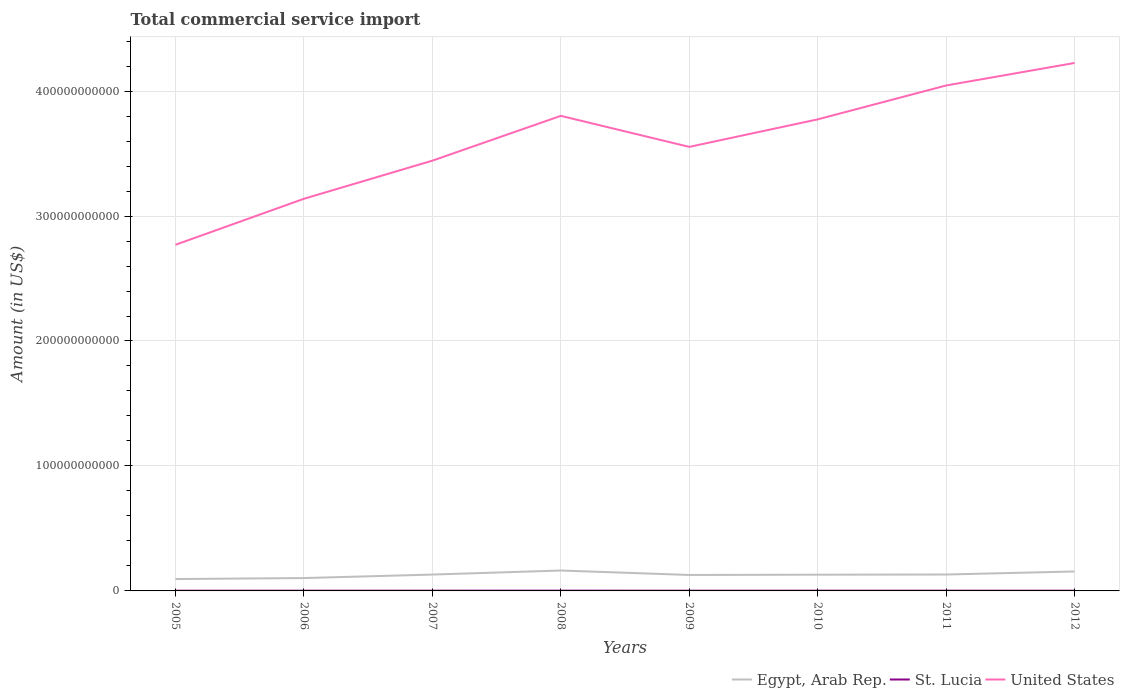Does the line corresponding to United States intersect with the line corresponding to St. Lucia?
Keep it short and to the point. No. Across all years, what is the maximum total commercial service import in St. Lucia?
Offer a very short reply. 1.74e+08. What is the total total commercial service import in Egypt, Arab Rep. in the graph?
Ensure brevity in your answer.  -2.80e+09. What is the difference between the highest and the second highest total commercial service import in United States?
Give a very brief answer. 1.46e+11. Is the total commercial service import in United States strictly greater than the total commercial service import in St. Lucia over the years?
Offer a terse response. No. How many lines are there?
Provide a short and direct response. 3. How many years are there in the graph?
Your answer should be very brief. 8. What is the difference between two consecutive major ticks on the Y-axis?
Your response must be concise. 1.00e+11. Does the graph contain any zero values?
Your answer should be compact. No. Where does the legend appear in the graph?
Provide a short and direct response. Bottom right. What is the title of the graph?
Make the answer very short. Total commercial service import. What is the label or title of the X-axis?
Offer a very short reply. Years. What is the label or title of the Y-axis?
Provide a short and direct response. Amount (in US$). What is the Amount (in US$) of Egypt, Arab Rep. in 2005?
Offer a very short reply. 9.51e+09. What is the Amount (in US$) in St. Lucia in 2005?
Your answer should be compact. 1.74e+08. What is the Amount (in US$) of United States in 2005?
Your answer should be compact. 2.77e+11. What is the Amount (in US$) of Egypt, Arab Rep. in 2006?
Your answer should be very brief. 1.03e+1. What is the Amount (in US$) of St. Lucia in 2006?
Your answer should be compact. 1.82e+08. What is the Amount (in US$) of United States in 2006?
Offer a terse response. 3.14e+11. What is the Amount (in US$) of Egypt, Arab Rep. in 2007?
Offer a terse response. 1.31e+1. What is the Amount (in US$) in St. Lucia in 2007?
Your answer should be very brief. 1.99e+08. What is the Amount (in US$) in United States in 2007?
Offer a terse response. 3.44e+11. What is the Amount (in US$) in Egypt, Arab Rep. in 2008?
Offer a very short reply. 1.63e+1. What is the Amount (in US$) of St. Lucia in 2008?
Your answer should be compact. 2.09e+08. What is the Amount (in US$) of United States in 2008?
Your answer should be compact. 3.80e+11. What is the Amount (in US$) in Egypt, Arab Rep. in 2009?
Your answer should be compact. 1.28e+1. What is the Amount (in US$) of St. Lucia in 2009?
Offer a very short reply. 1.85e+08. What is the Amount (in US$) of United States in 2009?
Offer a very short reply. 3.55e+11. What is the Amount (in US$) in Egypt, Arab Rep. in 2010?
Provide a short and direct response. 1.30e+1. What is the Amount (in US$) in St. Lucia in 2010?
Offer a terse response. 2.00e+08. What is the Amount (in US$) of United States in 2010?
Make the answer very short. 3.77e+11. What is the Amount (in US$) of Egypt, Arab Rep. in 2011?
Your response must be concise. 1.31e+1. What is the Amount (in US$) in St. Lucia in 2011?
Your answer should be compact. 1.97e+08. What is the Amount (in US$) in United States in 2011?
Give a very brief answer. 4.04e+11. What is the Amount (in US$) in Egypt, Arab Rep. in 2012?
Give a very brief answer. 1.56e+1. What is the Amount (in US$) of St. Lucia in 2012?
Your answer should be compact. 1.83e+08. What is the Amount (in US$) in United States in 2012?
Provide a short and direct response. 4.22e+11. Across all years, what is the maximum Amount (in US$) of Egypt, Arab Rep.?
Offer a very short reply. 1.63e+1. Across all years, what is the maximum Amount (in US$) of St. Lucia?
Your response must be concise. 2.09e+08. Across all years, what is the maximum Amount (in US$) in United States?
Provide a succinct answer. 4.22e+11. Across all years, what is the minimum Amount (in US$) of Egypt, Arab Rep.?
Your response must be concise. 9.51e+09. Across all years, what is the minimum Amount (in US$) in St. Lucia?
Ensure brevity in your answer.  1.74e+08. Across all years, what is the minimum Amount (in US$) of United States?
Provide a succinct answer. 2.77e+11. What is the total Amount (in US$) of Egypt, Arab Rep. in the graph?
Your response must be concise. 1.04e+11. What is the total Amount (in US$) of St. Lucia in the graph?
Offer a terse response. 1.53e+09. What is the total Amount (in US$) of United States in the graph?
Provide a short and direct response. 2.87e+12. What is the difference between the Amount (in US$) of Egypt, Arab Rep. in 2005 and that in 2006?
Offer a very short reply. -7.81e+08. What is the difference between the Amount (in US$) in St. Lucia in 2005 and that in 2006?
Your answer should be very brief. -8.19e+06. What is the difference between the Amount (in US$) of United States in 2005 and that in 2006?
Offer a terse response. -3.68e+1. What is the difference between the Amount (in US$) of Egypt, Arab Rep. in 2005 and that in 2007?
Your answer should be very brief. -3.58e+09. What is the difference between the Amount (in US$) in St. Lucia in 2005 and that in 2007?
Your answer should be very brief. -2.51e+07. What is the difference between the Amount (in US$) in United States in 2005 and that in 2007?
Offer a very short reply. -6.73e+1. What is the difference between the Amount (in US$) of Egypt, Arab Rep. in 2005 and that in 2008?
Your answer should be very brief. -6.83e+09. What is the difference between the Amount (in US$) in St. Lucia in 2005 and that in 2008?
Offer a very short reply. -3.48e+07. What is the difference between the Amount (in US$) of United States in 2005 and that in 2008?
Provide a succinct answer. -1.03e+11. What is the difference between the Amount (in US$) of Egypt, Arab Rep. in 2005 and that in 2009?
Ensure brevity in your answer.  -3.26e+09. What is the difference between the Amount (in US$) in St. Lucia in 2005 and that in 2009?
Give a very brief answer. -1.07e+07. What is the difference between the Amount (in US$) in United States in 2005 and that in 2009?
Provide a short and direct response. -7.83e+1. What is the difference between the Amount (in US$) in Egypt, Arab Rep. in 2005 and that in 2010?
Your answer should be very brief. -3.48e+09. What is the difference between the Amount (in US$) of St. Lucia in 2005 and that in 2010?
Offer a terse response. -2.58e+07. What is the difference between the Amount (in US$) of United States in 2005 and that in 2010?
Ensure brevity in your answer.  -1.00e+11. What is the difference between the Amount (in US$) of Egypt, Arab Rep. in 2005 and that in 2011?
Your answer should be very brief. -3.62e+09. What is the difference between the Amount (in US$) in St. Lucia in 2005 and that in 2011?
Your answer should be compact. -2.33e+07. What is the difference between the Amount (in US$) of United States in 2005 and that in 2011?
Keep it short and to the point. -1.27e+11. What is the difference between the Amount (in US$) in Egypt, Arab Rep. in 2005 and that in 2012?
Give a very brief answer. -6.05e+09. What is the difference between the Amount (in US$) of St. Lucia in 2005 and that in 2012?
Provide a succinct answer. -9.31e+06. What is the difference between the Amount (in US$) in United States in 2005 and that in 2012?
Your response must be concise. -1.46e+11. What is the difference between the Amount (in US$) in Egypt, Arab Rep. in 2006 and that in 2007?
Ensure brevity in your answer.  -2.80e+09. What is the difference between the Amount (in US$) in St. Lucia in 2006 and that in 2007?
Make the answer very short. -1.69e+07. What is the difference between the Amount (in US$) of United States in 2006 and that in 2007?
Make the answer very short. -3.05e+1. What is the difference between the Amount (in US$) in Egypt, Arab Rep. in 2006 and that in 2008?
Offer a terse response. -6.05e+09. What is the difference between the Amount (in US$) in St. Lucia in 2006 and that in 2008?
Provide a short and direct response. -2.66e+07. What is the difference between the Amount (in US$) of United States in 2006 and that in 2008?
Your response must be concise. -6.64e+1. What is the difference between the Amount (in US$) in Egypt, Arab Rep. in 2006 and that in 2009?
Make the answer very short. -2.48e+09. What is the difference between the Amount (in US$) in St. Lucia in 2006 and that in 2009?
Make the answer very short. -2.52e+06. What is the difference between the Amount (in US$) of United States in 2006 and that in 2009?
Offer a very short reply. -4.15e+1. What is the difference between the Amount (in US$) in Egypt, Arab Rep. in 2006 and that in 2010?
Provide a succinct answer. -2.70e+09. What is the difference between the Amount (in US$) in St. Lucia in 2006 and that in 2010?
Ensure brevity in your answer.  -1.76e+07. What is the difference between the Amount (in US$) of United States in 2006 and that in 2010?
Offer a terse response. -6.35e+1. What is the difference between the Amount (in US$) in Egypt, Arab Rep. in 2006 and that in 2011?
Your answer should be compact. -2.84e+09. What is the difference between the Amount (in US$) in St. Lucia in 2006 and that in 2011?
Offer a very short reply. -1.51e+07. What is the difference between the Amount (in US$) of United States in 2006 and that in 2011?
Offer a terse response. -9.07e+1. What is the difference between the Amount (in US$) in Egypt, Arab Rep. in 2006 and that in 2012?
Your answer should be compact. -5.27e+09. What is the difference between the Amount (in US$) in St. Lucia in 2006 and that in 2012?
Provide a short and direct response. -1.12e+06. What is the difference between the Amount (in US$) of United States in 2006 and that in 2012?
Provide a short and direct response. -1.09e+11. What is the difference between the Amount (in US$) in Egypt, Arab Rep. in 2007 and that in 2008?
Make the answer very short. -3.25e+09. What is the difference between the Amount (in US$) of St. Lucia in 2007 and that in 2008?
Your answer should be compact. -9.71e+06. What is the difference between the Amount (in US$) in United States in 2007 and that in 2008?
Provide a succinct answer. -3.59e+1. What is the difference between the Amount (in US$) of Egypt, Arab Rep. in 2007 and that in 2009?
Keep it short and to the point. 3.23e+08. What is the difference between the Amount (in US$) in St. Lucia in 2007 and that in 2009?
Provide a succinct answer. 1.44e+07. What is the difference between the Amount (in US$) of United States in 2007 and that in 2009?
Keep it short and to the point. -1.10e+1. What is the difference between the Amount (in US$) in Egypt, Arab Rep. in 2007 and that in 2010?
Make the answer very short. 9.68e+07. What is the difference between the Amount (in US$) of St. Lucia in 2007 and that in 2010?
Give a very brief answer. -6.63e+05. What is the difference between the Amount (in US$) in United States in 2007 and that in 2010?
Make the answer very short. -3.30e+1. What is the difference between the Amount (in US$) in Egypt, Arab Rep. in 2007 and that in 2011?
Provide a short and direct response. -4.13e+07. What is the difference between the Amount (in US$) in St. Lucia in 2007 and that in 2011?
Give a very brief answer. 1.82e+06. What is the difference between the Amount (in US$) of United States in 2007 and that in 2011?
Offer a terse response. -6.02e+1. What is the difference between the Amount (in US$) in Egypt, Arab Rep. in 2007 and that in 2012?
Make the answer very short. -2.47e+09. What is the difference between the Amount (in US$) of St. Lucia in 2007 and that in 2012?
Your answer should be very brief. 1.58e+07. What is the difference between the Amount (in US$) of United States in 2007 and that in 2012?
Keep it short and to the point. -7.82e+1. What is the difference between the Amount (in US$) of Egypt, Arab Rep. in 2008 and that in 2009?
Make the answer very short. 3.57e+09. What is the difference between the Amount (in US$) in St. Lucia in 2008 and that in 2009?
Keep it short and to the point. 2.41e+07. What is the difference between the Amount (in US$) in United States in 2008 and that in 2009?
Make the answer very short. 2.48e+1. What is the difference between the Amount (in US$) in Egypt, Arab Rep. in 2008 and that in 2010?
Keep it short and to the point. 3.34e+09. What is the difference between the Amount (in US$) of St. Lucia in 2008 and that in 2010?
Make the answer very short. 9.05e+06. What is the difference between the Amount (in US$) of United States in 2008 and that in 2010?
Your answer should be compact. 2.82e+09. What is the difference between the Amount (in US$) in Egypt, Arab Rep. in 2008 and that in 2011?
Offer a terse response. 3.21e+09. What is the difference between the Amount (in US$) in St. Lucia in 2008 and that in 2011?
Provide a succinct answer. 1.15e+07. What is the difference between the Amount (in US$) of United States in 2008 and that in 2011?
Offer a terse response. -2.43e+1. What is the difference between the Amount (in US$) of Egypt, Arab Rep. in 2008 and that in 2012?
Give a very brief answer. 7.78e+08. What is the difference between the Amount (in US$) of St. Lucia in 2008 and that in 2012?
Make the answer very short. 2.55e+07. What is the difference between the Amount (in US$) in United States in 2008 and that in 2012?
Ensure brevity in your answer.  -4.23e+1. What is the difference between the Amount (in US$) in Egypt, Arab Rep. in 2009 and that in 2010?
Your answer should be compact. -2.26e+08. What is the difference between the Amount (in US$) of St. Lucia in 2009 and that in 2010?
Ensure brevity in your answer.  -1.51e+07. What is the difference between the Amount (in US$) of United States in 2009 and that in 2010?
Offer a very short reply. -2.20e+1. What is the difference between the Amount (in US$) of Egypt, Arab Rep. in 2009 and that in 2011?
Provide a short and direct response. -3.64e+08. What is the difference between the Amount (in US$) of St. Lucia in 2009 and that in 2011?
Make the answer very short. -1.26e+07. What is the difference between the Amount (in US$) in United States in 2009 and that in 2011?
Ensure brevity in your answer.  -4.91e+1. What is the difference between the Amount (in US$) in Egypt, Arab Rep. in 2009 and that in 2012?
Provide a succinct answer. -2.79e+09. What is the difference between the Amount (in US$) in St. Lucia in 2009 and that in 2012?
Offer a very short reply. 1.40e+06. What is the difference between the Amount (in US$) of United States in 2009 and that in 2012?
Provide a short and direct response. -6.72e+1. What is the difference between the Amount (in US$) of Egypt, Arab Rep. in 2010 and that in 2011?
Your answer should be very brief. -1.38e+08. What is the difference between the Amount (in US$) of St. Lucia in 2010 and that in 2011?
Make the answer very short. 2.48e+06. What is the difference between the Amount (in US$) in United States in 2010 and that in 2011?
Your answer should be very brief. -2.71e+1. What is the difference between the Amount (in US$) in Egypt, Arab Rep. in 2010 and that in 2012?
Offer a very short reply. -2.57e+09. What is the difference between the Amount (in US$) in St. Lucia in 2010 and that in 2012?
Give a very brief answer. 1.65e+07. What is the difference between the Amount (in US$) in United States in 2010 and that in 2012?
Your response must be concise. -4.51e+1. What is the difference between the Amount (in US$) of Egypt, Arab Rep. in 2011 and that in 2012?
Keep it short and to the point. -2.43e+09. What is the difference between the Amount (in US$) of St. Lucia in 2011 and that in 2012?
Give a very brief answer. 1.40e+07. What is the difference between the Amount (in US$) in United States in 2011 and that in 2012?
Make the answer very short. -1.80e+1. What is the difference between the Amount (in US$) in Egypt, Arab Rep. in 2005 and the Amount (in US$) in St. Lucia in 2006?
Give a very brief answer. 9.33e+09. What is the difference between the Amount (in US$) of Egypt, Arab Rep. in 2005 and the Amount (in US$) of United States in 2006?
Ensure brevity in your answer.  -3.04e+11. What is the difference between the Amount (in US$) of St. Lucia in 2005 and the Amount (in US$) of United States in 2006?
Your answer should be very brief. -3.14e+11. What is the difference between the Amount (in US$) of Egypt, Arab Rep. in 2005 and the Amount (in US$) of St. Lucia in 2007?
Give a very brief answer. 9.31e+09. What is the difference between the Amount (in US$) in Egypt, Arab Rep. in 2005 and the Amount (in US$) in United States in 2007?
Your response must be concise. -3.35e+11. What is the difference between the Amount (in US$) of St. Lucia in 2005 and the Amount (in US$) of United States in 2007?
Your answer should be compact. -3.44e+11. What is the difference between the Amount (in US$) of Egypt, Arab Rep. in 2005 and the Amount (in US$) of St. Lucia in 2008?
Your answer should be very brief. 9.30e+09. What is the difference between the Amount (in US$) in Egypt, Arab Rep. in 2005 and the Amount (in US$) in United States in 2008?
Make the answer very short. -3.71e+11. What is the difference between the Amount (in US$) in St. Lucia in 2005 and the Amount (in US$) in United States in 2008?
Give a very brief answer. -3.80e+11. What is the difference between the Amount (in US$) of Egypt, Arab Rep. in 2005 and the Amount (in US$) of St. Lucia in 2009?
Provide a short and direct response. 9.32e+09. What is the difference between the Amount (in US$) in Egypt, Arab Rep. in 2005 and the Amount (in US$) in United States in 2009?
Offer a very short reply. -3.46e+11. What is the difference between the Amount (in US$) in St. Lucia in 2005 and the Amount (in US$) in United States in 2009?
Your response must be concise. -3.55e+11. What is the difference between the Amount (in US$) of Egypt, Arab Rep. in 2005 and the Amount (in US$) of St. Lucia in 2010?
Provide a succinct answer. 9.31e+09. What is the difference between the Amount (in US$) in Egypt, Arab Rep. in 2005 and the Amount (in US$) in United States in 2010?
Give a very brief answer. -3.68e+11. What is the difference between the Amount (in US$) of St. Lucia in 2005 and the Amount (in US$) of United States in 2010?
Ensure brevity in your answer.  -3.77e+11. What is the difference between the Amount (in US$) in Egypt, Arab Rep. in 2005 and the Amount (in US$) in St. Lucia in 2011?
Your answer should be compact. 9.31e+09. What is the difference between the Amount (in US$) in Egypt, Arab Rep. in 2005 and the Amount (in US$) in United States in 2011?
Your answer should be very brief. -3.95e+11. What is the difference between the Amount (in US$) of St. Lucia in 2005 and the Amount (in US$) of United States in 2011?
Ensure brevity in your answer.  -4.04e+11. What is the difference between the Amount (in US$) in Egypt, Arab Rep. in 2005 and the Amount (in US$) in St. Lucia in 2012?
Offer a terse response. 9.32e+09. What is the difference between the Amount (in US$) in Egypt, Arab Rep. in 2005 and the Amount (in US$) in United States in 2012?
Offer a very short reply. -4.13e+11. What is the difference between the Amount (in US$) of St. Lucia in 2005 and the Amount (in US$) of United States in 2012?
Your answer should be compact. -4.22e+11. What is the difference between the Amount (in US$) in Egypt, Arab Rep. in 2006 and the Amount (in US$) in St. Lucia in 2007?
Offer a terse response. 1.01e+1. What is the difference between the Amount (in US$) in Egypt, Arab Rep. in 2006 and the Amount (in US$) in United States in 2007?
Make the answer very short. -3.34e+11. What is the difference between the Amount (in US$) in St. Lucia in 2006 and the Amount (in US$) in United States in 2007?
Give a very brief answer. -3.44e+11. What is the difference between the Amount (in US$) in Egypt, Arab Rep. in 2006 and the Amount (in US$) in St. Lucia in 2008?
Offer a very short reply. 1.01e+1. What is the difference between the Amount (in US$) of Egypt, Arab Rep. in 2006 and the Amount (in US$) of United States in 2008?
Keep it short and to the point. -3.70e+11. What is the difference between the Amount (in US$) in St. Lucia in 2006 and the Amount (in US$) in United States in 2008?
Make the answer very short. -3.80e+11. What is the difference between the Amount (in US$) of Egypt, Arab Rep. in 2006 and the Amount (in US$) of St. Lucia in 2009?
Offer a terse response. 1.01e+1. What is the difference between the Amount (in US$) of Egypt, Arab Rep. in 2006 and the Amount (in US$) of United States in 2009?
Give a very brief answer. -3.45e+11. What is the difference between the Amount (in US$) of St. Lucia in 2006 and the Amount (in US$) of United States in 2009?
Your answer should be very brief. -3.55e+11. What is the difference between the Amount (in US$) of Egypt, Arab Rep. in 2006 and the Amount (in US$) of St. Lucia in 2010?
Your answer should be very brief. 1.01e+1. What is the difference between the Amount (in US$) in Egypt, Arab Rep. in 2006 and the Amount (in US$) in United States in 2010?
Make the answer very short. -3.67e+11. What is the difference between the Amount (in US$) of St. Lucia in 2006 and the Amount (in US$) of United States in 2010?
Provide a succinct answer. -3.77e+11. What is the difference between the Amount (in US$) of Egypt, Arab Rep. in 2006 and the Amount (in US$) of St. Lucia in 2011?
Your answer should be very brief. 1.01e+1. What is the difference between the Amount (in US$) in Egypt, Arab Rep. in 2006 and the Amount (in US$) in United States in 2011?
Your answer should be compact. -3.94e+11. What is the difference between the Amount (in US$) of St. Lucia in 2006 and the Amount (in US$) of United States in 2011?
Ensure brevity in your answer.  -4.04e+11. What is the difference between the Amount (in US$) of Egypt, Arab Rep. in 2006 and the Amount (in US$) of St. Lucia in 2012?
Give a very brief answer. 1.01e+1. What is the difference between the Amount (in US$) of Egypt, Arab Rep. in 2006 and the Amount (in US$) of United States in 2012?
Provide a short and direct response. -4.12e+11. What is the difference between the Amount (in US$) in St. Lucia in 2006 and the Amount (in US$) in United States in 2012?
Give a very brief answer. -4.22e+11. What is the difference between the Amount (in US$) of Egypt, Arab Rep. in 2007 and the Amount (in US$) of St. Lucia in 2008?
Make the answer very short. 1.29e+1. What is the difference between the Amount (in US$) of Egypt, Arab Rep. in 2007 and the Amount (in US$) of United States in 2008?
Give a very brief answer. -3.67e+11. What is the difference between the Amount (in US$) in St. Lucia in 2007 and the Amount (in US$) in United States in 2008?
Ensure brevity in your answer.  -3.80e+11. What is the difference between the Amount (in US$) in Egypt, Arab Rep. in 2007 and the Amount (in US$) in St. Lucia in 2009?
Provide a short and direct response. 1.29e+1. What is the difference between the Amount (in US$) of Egypt, Arab Rep. in 2007 and the Amount (in US$) of United States in 2009?
Provide a short and direct response. -3.42e+11. What is the difference between the Amount (in US$) in St. Lucia in 2007 and the Amount (in US$) in United States in 2009?
Make the answer very short. -3.55e+11. What is the difference between the Amount (in US$) of Egypt, Arab Rep. in 2007 and the Amount (in US$) of St. Lucia in 2010?
Provide a succinct answer. 1.29e+1. What is the difference between the Amount (in US$) of Egypt, Arab Rep. in 2007 and the Amount (in US$) of United States in 2010?
Offer a terse response. -3.64e+11. What is the difference between the Amount (in US$) of St. Lucia in 2007 and the Amount (in US$) of United States in 2010?
Offer a terse response. -3.77e+11. What is the difference between the Amount (in US$) of Egypt, Arab Rep. in 2007 and the Amount (in US$) of St. Lucia in 2011?
Make the answer very short. 1.29e+1. What is the difference between the Amount (in US$) in Egypt, Arab Rep. in 2007 and the Amount (in US$) in United States in 2011?
Offer a terse response. -3.91e+11. What is the difference between the Amount (in US$) of St. Lucia in 2007 and the Amount (in US$) of United States in 2011?
Your response must be concise. -4.04e+11. What is the difference between the Amount (in US$) in Egypt, Arab Rep. in 2007 and the Amount (in US$) in St. Lucia in 2012?
Provide a succinct answer. 1.29e+1. What is the difference between the Amount (in US$) in Egypt, Arab Rep. in 2007 and the Amount (in US$) in United States in 2012?
Make the answer very short. -4.09e+11. What is the difference between the Amount (in US$) in St. Lucia in 2007 and the Amount (in US$) in United States in 2012?
Give a very brief answer. -4.22e+11. What is the difference between the Amount (in US$) of Egypt, Arab Rep. in 2008 and the Amount (in US$) of St. Lucia in 2009?
Your answer should be compact. 1.62e+1. What is the difference between the Amount (in US$) of Egypt, Arab Rep. in 2008 and the Amount (in US$) of United States in 2009?
Your response must be concise. -3.39e+11. What is the difference between the Amount (in US$) in St. Lucia in 2008 and the Amount (in US$) in United States in 2009?
Ensure brevity in your answer.  -3.55e+11. What is the difference between the Amount (in US$) in Egypt, Arab Rep. in 2008 and the Amount (in US$) in St. Lucia in 2010?
Make the answer very short. 1.61e+1. What is the difference between the Amount (in US$) in Egypt, Arab Rep. in 2008 and the Amount (in US$) in United States in 2010?
Give a very brief answer. -3.61e+11. What is the difference between the Amount (in US$) of St. Lucia in 2008 and the Amount (in US$) of United States in 2010?
Make the answer very short. -3.77e+11. What is the difference between the Amount (in US$) of Egypt, Arab Rep. in 2008 and the Amount (in US$) of St. Lucia in 2011?
Provide a succinct answer. 1.61e+1. What is the difference between the Amount (in US$) of Egypt, Arab Rep. in 2008 and the Amount (in US$) of United States in 2011?
Your response must be concise. -3.88e+11. What is the difference between the Amount (in US$) of St. Lucia in 2008 and the Amount (in US$) of United States in 2011?
Keep it short and to the point. -4.04e+11. What is the difference between the Amount (in US$) in Egypt, Arab Rep. in 2008 and the Amount (in US$) in St. Lucia in 2012?
Offer a terse response. 1.62e+1. What is the difference between the Amount (in US$) of Egypt, Arab Rep. in 2008 and the Amount (in US$) of United States in 2012?
Your answer should be very brief. -4.06e+11. What is the difference between the Amount (in US$) in St. Lucia in 2008 and the Amount (in US$) in United States in 2012?
Make the answer very short. -4.22e+11. What is the difference between the Amount (in US$) of Egypt, Arab Rep. in 2009 and the Amount (in US$) of St. Lucia in 2010?
Give a very brief answer. 1.26e+1. What is the difference between the Amount (in US$) in Egypt, Arab Rep. in 2009 and the Amount (in US$) in United States in 2010?
Offer a very short reply. -3.65e+11. What is the difference between the Amount (in US$) of St. Lucia in 2009 and the Amount (in US$) of United States in 2010?
Your response must be concise. -3.77e+11. What is the difference between the Amount (in US$) of Egypt, Arab Rep. in 2009 and the Amount (in US$) of St. Lucia in 2011?
Your answer should be very brief. 1.26e+1. What is the difference between the Amount (in US$) of Egypt, Arab Rep. in 2009 and the Amount (in US$) of United States in 2011?
Your response must be concise. -3.92e+11. What is the difference between the Amount (in US$) of St. Lucia in 2009 and the Amount (in US$) of United States in 2011?
Make the answer very short. -4.04e+11. What is the difference between the Amount (in US$) of Egypt, Arab Rep. in 2009 and the Amount (in US$) of St. Lucia in 2012?
Offer a very short reply. 1.26e+1. What is the difference between the Amount (in US$) of Egypt, Arab Rep. in 2009 and the Amount (in US$) of United States in 2012?
Your answer should be very brief. -4.10e+11. What is the difference between the Amount (in US$) in St. Lucia in 2009 and the Amount (in US$) in United States in 2012?
Your response must be concise. -4.22e+11. What is the difference between the Amount (in US$) of Egypt, Arab Rep. in 2010 and the Amount (in US$) of St. Lucia in 2011?
Your answer should be compact. 1.28e+1. What is the difference between the Amount (in US$) of Egypt, Arab Rep. in 2010 and the Amount (in US$) of United States in 2011?
Ensure brevity in your answer.  -3.91e+11. What is the difference between the Amount (in US$) in St. Lucia in 2010 and the Amount (in US$) in United States in 2011?
Give a very brief answer. -4.04e+11. What is the difference between the Amount (in US$) of Egypt, Arab Rep. in 2010 and the Amount (in US$) of St. Lucia in 2012?
Provide a short and direct response. 1.28e+1. What is the difference between the Amount (in US$) in Egypt, Arab Rep. in 2010 and the Amount (in US$) in United States in 2012?
Keep it short and to the point. -4.10e+11. What is the difference between the Amount (in US$) of St. Lucia in 2010 and the Amount (in US$) of United States in 2012?
Make the answer very short. -4.22e+11. What is the difference between the Amount (in US$) of Egypt, Arab Rep. in 2011 and the Amount (in US$) of St. Lucia in 2012?
Your answer should be very brief. 1.29e+1. What is the difference between the Amount (in US$) in Egypt, Arab Rep. in 2011 and the Amount (in US$) in United States in 2012?
Provide a succinct answer. -4.09e+11. What is the difference between the Amount (in US$) of St. Lucia in 2011 and the Amount (in US$) of United States in 2012?
Your answer should be compact. -4.22e+11. What is the average Amount (in US$) of Egypt, Arab Rep. per year?
Your answer should be compact. 1.30e+1. What is the average Amount (in US$) in St. Lucia per year?
Your answer should be very brief. 1.91e+08. What is the average Amount (in US$) in United States per year?
Make the answer very short. 3.59e+11. In the year 2005, what is the difference between the Amount (in US$) in Egypt, Arab Rep. and Amount (in US$) in St. Lucia?
Make the answer very short. 9.33e+09. In the year 2005, what is the difference between the Amount (in US$) in Egypt, Arab Rep. and Amount (in US$) in United States?
Offer a very short reply. -2.67e+11. In the year 2005, what is the difference between the Amount (in US$) in St. Lucia and Amount (in US$) in United States?
Offer a terse response. -2.77e+11. In the year 2006, what is the difference between the Amount (in US$) in Egypt, Arab Rep. and Amount (in US$) in St. Lucia?
Your answer should be compact. 1.01e+1. In the year 2006, what is the difference between the Amount (in US$) of Egypt, Arab Rep. and Amount (in US$) of United States?
Provide a short and direct response. -3.04e+11. In the year 2006, what is the difference between the Amount (in US$) in St. Lucia and Amount (in US$) in United States?
Make the answer very short. -3.14e+11. In the year 2007, what is the difference between the Amount (in US$) of Egypt, Arab Rep. and Amount (in US$) of St. Lucia?
Your response must be concise. 1.29e+1. In the year 2007, what is the difference between the Amount (in US$) of Egypt, Arab Rep. and Amount (in US$) of United States?
Keep it short and to the point. -3.31e+11. In the year 2007, what is the difference between the Amount (in US$) of St. Lucia and Amount (in US$) of United States?
Provide a succinct answer. -3.44e+11. In the year 2008, what is the difference between the Amount (in US$) in Egypt, Arab Rep. and Amount (in US$) in St. Lucia?
Your answer should be compact. 1.61e+1. In the year 2008, what is the difference between the Amount (in US$) of Egypt, Arab Rep. and Amount (in US$) of United States?
Make the answer very short. -3.64e+11. In the year 2008, what is the difference between the Amount (in US$) of St. Lucia and Amount (in US$) of United States?
Keep it short and to the point. -3.80e+11. In the year 2009, what is the difference between the Amount (in US$) in Egypt, Arab Rep. and Amount (in US$) in St. Lucia?
Keep it short and to the point. 1.26e+1. In the year 2009, what is the difference between the Amount (in US$) of Egypt, Arab Rep. and Amount (in US$) of United States?
Offer a terse response. -3.43e+11. In the year 2009, what is the difference between the Amount (in US$) in St. Lucia and Amount (in US$) in United States?
Your response must be concise. -3.55e+11. In the year 2010, what is the difference between the Amount (in US$) of Egypt, Arab Rep. and Amount (in US$) of St. Lucia?
Your answer should be very brief. 1.28e+1. In the year 2010, what is the difference between the Amount (in US$) of Egypt, Arab Rep. and Amount (in US$) of United States?
Offer a very short reply. -3.64e+11. In the year 2010, what is the difference between the Amount (in US$) of St. Lucia and Amount (in US$) of United States?
Ensure brevity in your answer.  -3.77e+11. In the year 2011, what is the difference between the Amount (in US$) of Egypt, Arab Rep. and Amount (in US$) of St. Lucia?
Your answer should be compact. 1.29e+1. In the year 2011, what is the difference between the Amount (in US$) in Egypt, Arab Rep. and Amount (in US$) in United States?
Your answer should be compact. -3.91e+11. In the year 2011, what is the difference between the Amount (in US$) of St. Lucia and Amount (in US$) of United States?
Offer a very short reply. -4.04e+11. In the year 2012, what is the difference between the Amount (in US$) of Egypt, Arab Rep. and Amount (in US$) of St. Lucia?
Offer a very short reply. 1.54e+1. In the year 2012, what is the difference between the Amount (in US$) of Egypt, Arab Rep. and Amount (in US$) of United States?
Ensure brevity in your answer.  -4.07e+11. In the year 2012, what is the difference between the Amount (in US$) of St. Lucia and Amount (in US$) of United States?
Ensure brevity in your answer.  -4.22e+11. What is the ratio of the Amount (in US$) of Egypt, Arab Rep. in 2005 to that in 2006?
Offer a terse response. 0.92. What is the ratio of the Amount (in US$) of St. Lucia in 2005 to that in 2006?
Make the answer very short. 0.96. What is the ratio of the Amount (in US$) of United States in 2005 to that in 2006?
Offer a terse response. 0.88. What is the ratio of the Amount (in US$) of Egypt, Arab Rep. in 2005 to that in 2007?
Your answer should be very brief. 0.73. What is the ratio of the Amount (in US$) in St. Lucia in 2005 to that in 2007?
Give a very brief answer. 0.87. What is the ratio of the Amount (in US$) of United States in 2005 to that in 2007?
Offer a terse response. 0.8. What is the ratio of the Amount (in US$) of Egypt, Arab Rep. in 2005 to that in 2008?
Provide a succinct answer. 0.58. What is the ratio of the Amount (in US$) of St. Lucia in 2005 to that in 2008?
Give a very brief answer. 0.83. What is the ratio of the Amount (in US$) in United States in 2005 to that in 2008?
Offer a very short reply. 0.73. What is the ratio of the Amount (in US$) in Egypt, Arab Rep. in 2005 to that in 2009?
Give a very brief answer. 0.74. What is the ratio of the Amount (in US$) in St. Lucia in 2005 to that in 2009?
Offer a very short reply. 0.94. What is the ratio of the Amount (in US$) in United States in 2005 to that in 2009?
Keep it short and to the point. 0.78. What is the ratio of the Amount (in US$) of Egypt, Arab Rep. in 2005 to that in 2010?
Give a very brief answer. 0.73. What is the ratio of the Amount (in US$) of St. Lucia in 2005 to that in 2010?
Provide a short and direct response. 0.87. What is the ratio of the Amount (in US$) in United States in 2005 to that in 2010?
Offer a very short reply. 0.73. What is the ratio of the Amount (in US$) of Egypt, Arab Rep. in 2005 to that in 2011?
Ensure brevity in your answer.  0.72. What is the ratio of the Amount (in US$) of St. Lucia in 2005 to that in 2011?
Give a very brief answer. 0.88. What is the ratio of the Amount (in US$) of United States in 2005 to that in 2011?
Your answer should be compact. 0.68. What is the ratio of the Amount (in US$) in Egypt, Arab Rep. in 2005 to that in 2012?
Your answer should be very brief. 0.61. What is the ratio of the Amount (in US$) of St. Lucia in 2005 to that in 2012?
Your answer should be compact. 0.95. What is the ratio of the Amount (in US$) of United States in 2005 to that in 2012?
Your answer should be compact. 0.66. What is the ratio of the Amount (in US$) of Egypt, Arab Rep. in 2006 to that in 2007?
Provide a succinct answer. 0.79. What is the ratio of the Amount (in US$) in St. Lucia in 2006 to that in 2007?
Make the answer very short. 0.92. What is the ratio of the Amount (in US$) in United States in 2006 to that in 2007?
Your answer should be compact. 0.91. What is the ratio of the Amount (in US$) in Egypt, Arab Rep. in 2006 to that in 2008?
Keep it short and to the point. 0.63. What is the ratio of the Amount (in US$) of St. Lucia in 2006 to that in 2008?
Your answer should be very brief. 0.87. What is the ratio of the Amount (in US$) in United States in 2006 to that in 2008?
Provide a short and direct response. 0.83. What is the ratio of the Amount (in US$) in Egypt, Arab Rep. in 2006 to that in 2009?
Provide a succinct answer. 0.81. What is the ratio of the Amount (in US$) in St. Lucia in 2006 to that in 2009?
Make the answer very short. 0.99. What is the ratio of the Amount (in US$) in United States in 2006 to that in 2009?
Your response must be concise. 0.88. What is the ratio of the Amount (in US$) of Egypt, Arab Rep. in 2006 to that in 2010?
Ensure brevity in your answer.  0.79. What is the ratio of the Amount (in US$) in St. Lucia in 2006 to that in 2010?
Give a very brief answer. 0.91. What is the ratio of the Amount (in US$) in United States in 2006 to that in 2010?
Your answer should be compact. 0.83. What is the ratio of the Amount (in US$) in Egypt, Arab Rep. in 2006 to that in 2011?
Provide a short and direct response. 0.78. What is the ratio of the Amount (in US$) of St. Lucia in 2006 to that in 2011?
Your answer should be very brief. 0.92. What is the ratio of the Amount (in US$) of United States in 2006 to that in 2011?
Ensure brevity in your answer.  0.78. What is the ratio of the Amount (in US$) of Egypt, Arab Rep. in 2006 to that in 2012?
Provide a succinct answer. 0.66. What is the ratio of the Amount (in US$) in St. Lucia in 2006 to that in 2012?
Offer a very short reply. 0.99. What is the ratio of the Amount (in US$) in United States in 2006 to that in 2012?
Provide a succinct answer. 0.74. What is the ratio of the Amount (in US$) of Egypt, Arab Rep. in 2007 to that in 2008?
Provide a short and direct response. 0.8. What is the ratio of the Amount (in US$) of St. Lucia in 2007 to that in 2008?
Your answer should be very brief. 0.95. What is the ratio of the Amount (in US$) of United States in 2007 to that in 2008?
Provide a short and direct response. 0.91. What is the ratio of the Amount (in US$) of Egypt, Arab Rep. in 2007 to that in 2009?
Offer a terse response. 1.03. What is the ratio of the Amount (in US$) of St. Lucia in 2007 to that in 2009?
Your answer should be very brief. 1.08. What is the ratio of the Amount (in US$) of United States in 2007 to that in 2009?
Provide a succinct answer. 0.97. What is the ratio of the Amount (in US$) of Egypt, Arab Rep. in 2007 to that in 2010?
Give a very brief answer. 1.01. What is the ratio of the Amount (in US$) of United States in 2007 to that in 2010?
Give a very brief answer. 0.91. What is the ratio of the Amount (in US$) in Egypt, Arab Rep. in 2007 to that in 2011?
Your response must be concise. 1. What is the ratio of the Amount (in US$) of St. Lucia in 2007 to that in 2011?
Provide a succinct answer. 1.01. What is the ratio of the Amount (in US$) in United States in 2007 to that in 2011?
Ensure brevity in your answer.  0.85. What is the ratio of the Amount (in US$) of Egypt, Arab Rep. in 2007 to that in 2012?
Provide a short and direct response. 0.84. What is the ratio of the Amount (in US$) of St. Lucia in 2007 to that in 2012?
Provide a succinct answer. 1.09. What is the ratio of the Amount (in US$) of United States in 2007 to that in 2012?
Provide a succinct answer. 0.81. What is the ratio of the Amount (in US$) of Egypt, Arab Rep. in 2008 to that in 2009?
Offer a terse response. 1.28. What is the ratio of the Amount (in US$) in St. Lucia in 2008 to that in 2009?
Keep it short and to the point. 1.13. What is the ratio of the Amount (in US$) in United States in 2008 to that in 2009?
Give a very brief answer. 1.07. What is the ratio of the Amount (in US$) of Egypt, Arab Rep. in 2008 to that in 2010?
Offer a very short reply. 1.26. What is the ratio of the Amount (in US$) in St. Lucia in 2008 to that in 2010?
Provide a short and direct response. 1.05. What is the ratio of the Amount (in US$) of United States in 2008 to that in 2010?
Offer a terse response. 1.01. What is the ratio of the Amount (in US$) in Egypt, Arab Rep. in 2008 to that in 2011?
Give a very brief answer. 1.24. What is the ratio of the Amount (in US$) in St. Lucia in 2008 to that in 2011?
Your answer should be very brief. 1.06. What is the ratio of the Amount (in US$) in United States in 2008 to that in 2011?
Offer a terse response. 0.94. What is the ratio of the Amount (in US$) in St. Lucia in 2008 to that in 2012?
Ensure brevity in your answer.  1.14. What is the ratio of the Amount (in US$) of United States in 2008 to that in 2012?
Offer a terse response. 0.9. What is the ratio of the Amount (in US$) of Egypt, Arab Rep. in 2009 to that in 2010?
Make the answer very short. 0.98. What is the ratio of the Amount (in US$) of St. Lucia in 2009 to that in 2010?
Offer a terse response. 0.92. What is the ratio of the Amount (in US$) of United States in 2009 to that in 2010?
Offer a very short reply. 0.94. What is the ratio of the Amount (in US$) of Egypt, Arab Rep. in 2009 to that in 2011?
Provide a short and direct response. 0.97. What is the ratio of the Amount (in US$) in St. Lucia in 2009 to that in 2011?
Your answer should be compact. 0.94. What is the ratio of the Amount (in US$) in United States in 2009 to that in 2011?
Offer a very short reply. 0.88. What is the ratio of the Amount (in US$) of Egypt, Arab Rep. in 2009 to that in 2012?
Keep it short and to the point. 0.82. What is the ratio of the Amount (in US$) in St. Lucia in 2009 to that in 2012?
Offer a terse response. 1.01. What is the ratio of the Amount (in US$) in United States in 2009 to that in 2012?
Ensure brevity in your answer.  0.84. What is the ratio of the Amount (in US$) in Egypt, Arab Rep. in 2010 to that in 2011?
Ensure brevity in your answer.  0.99. What is the ratio of the Amount (in US$) in St. Lucia in 2010 to that in 2011?
Ensure brevity in your answer.  1.01. What is the ratio of the Amount (in US$) of United States in 2010 to that in 2011?
Ensure brevity in your answer.  0.93. What is the ratio of the Amount (in US$) in Egypt, Arab Rep. in 2010 to that in 2012?
Your response must be concise. 0.84. What is the ratio of the Amount (in US$) of St. Lucia in 2010 to that in 2012?
Ensure brevity in your answer.  1.09. What is the ratio of the Amount (in US$) of United States in 2010 to that in 2012?
Ensure brevity in your answer.  0.89. What is the ratio of the Amount (in US$) in Egypt, Arab Rep. in 2011 to that in 2012?
Keep it short and to the point. 0.84. What is the ratio of the Amount (in US$) in St. Lucia in 2011 to that in 2012?
Give a very brief answer. 1.08. What is the ratio of the Amount (in US$) in United States in 2011 to that in 2012?
Keep it short and to the point. 0.96. What is the difference between the highest and the second highest Amount (in US$) in Egypt, Arab Rep.?
Ensure brevity in your answer.  7.78e+08. What is the difference between the highest and the second highest Amount (in US$) of St. Lucia?
Give a very brief answer. 9.05e+06. What is the difference between the highest and the second highest Amount (in US$) of United States?
Your answer should be compact. 1.80e+1. What is the difference between the highest and the lowest Amount (in US$) in Egypt, Arab Rep.?
Your response must be concise. 6.83e+09. What is the difference between the highest and the lowest Amount (in US$) in St. Lucia?
Make the answer very short. 3.48e+07. What is the difference between the highest and the lowest Amount (in US$) of United States?
Make the answer very short. 1.46e+11. 